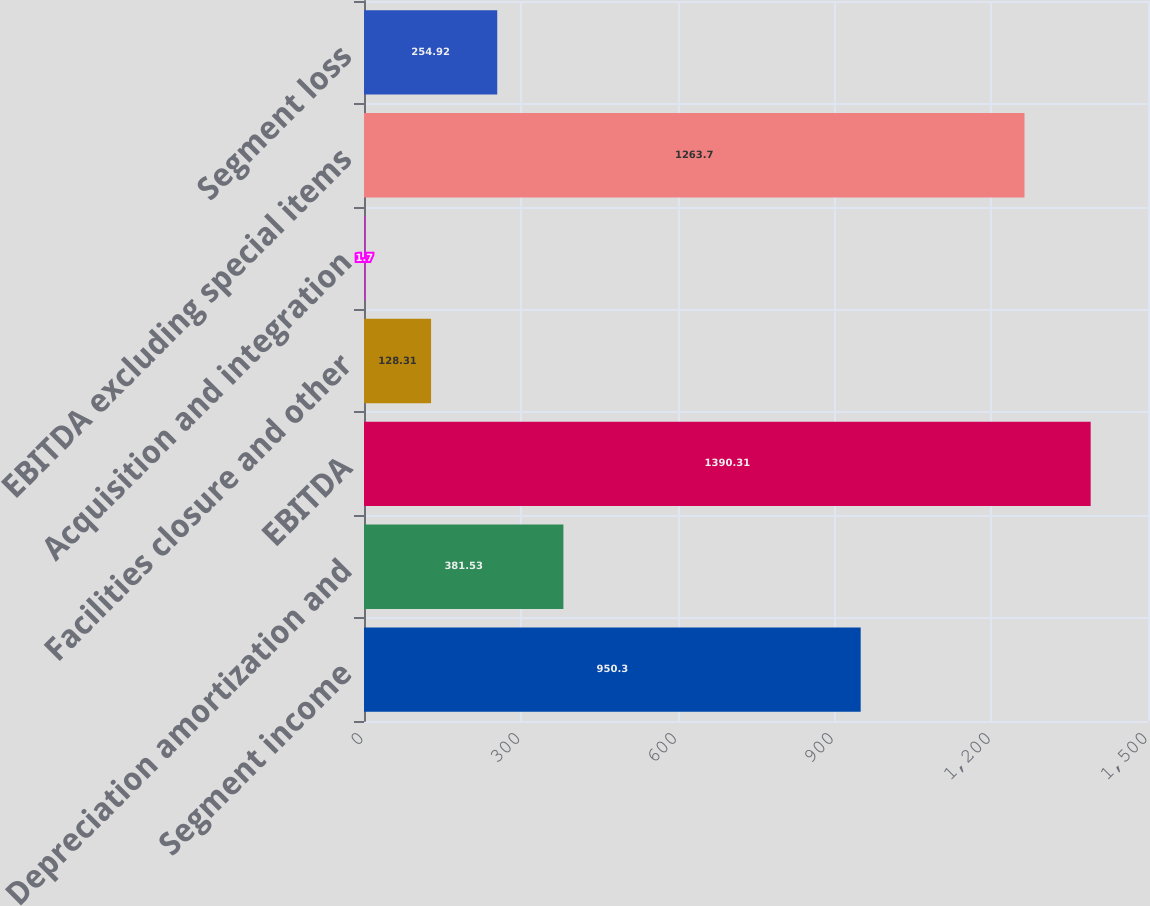<chart> <loc_0><loc_0><loc_500><loc_500><bar_chart><fcel>Segment income<fcel>Depreciation amortization and<fcel>EBITDA<fcel>Facilities closure and other<fcel>Acquisition and integration<fcel>EBITDA excluding special items<fcel>Segment loss<nl><fcel>950.3<fcel>381.53<fcel>1390.31<fcel>128.31<fcel>1.7<fcel>1263.7<fcel>254.92<nl></chart> 